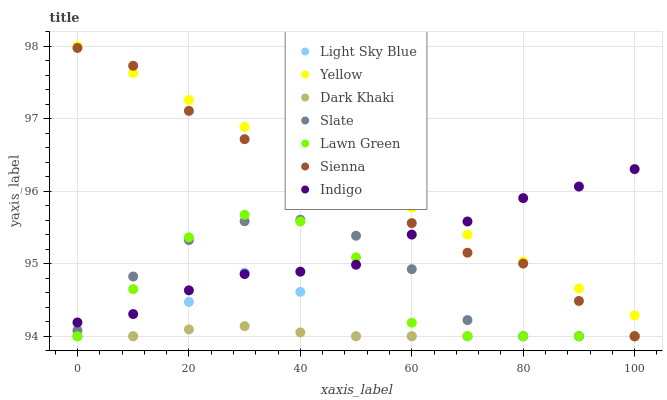Does Dark Khaki have the minimum area under the curve?
Answer yes or no. Yes. Does Yellow have the maximum area under the curve?
Answer yes or no. Yes. Does Indigo have the minimum area under the curve?
Answer yes or no. No. Does Indigo have the maximum area under the curve?
Answer yes or no. No. Is Yellow the smoothest?
Answer yes or no. Yes. Is Lawn Green the roughest?
Answer yes or no. Yes. Is Indigo the smoothest?
Answer yes or no. No. Is Indigo the roughest?
Answer yes or no. No. Does Lawn Green have the lowest value?
Answer yes or no. Yes. Does Indigo have the lowest value?
Answer yes or no. No. Does Yellow have the highest value?
Answer yes or no. Yes. Does Indigo have the highest value?
Answer yes or no. No. Is Lawn Green less than Yellow?
Answer yes or no. Yes. Is Yellow greater than Lawn Green?
Answer yes or no. Yes. Does Slate intersect Sienna?
Answer yes or no. Yes. Is Slate less than Sienna?
Answer yes or no. No. Is Slate greater than Sienna?
Answer yes or no. No. Does Lawn Green intersect Yellow?
Answer yes or no. No. 